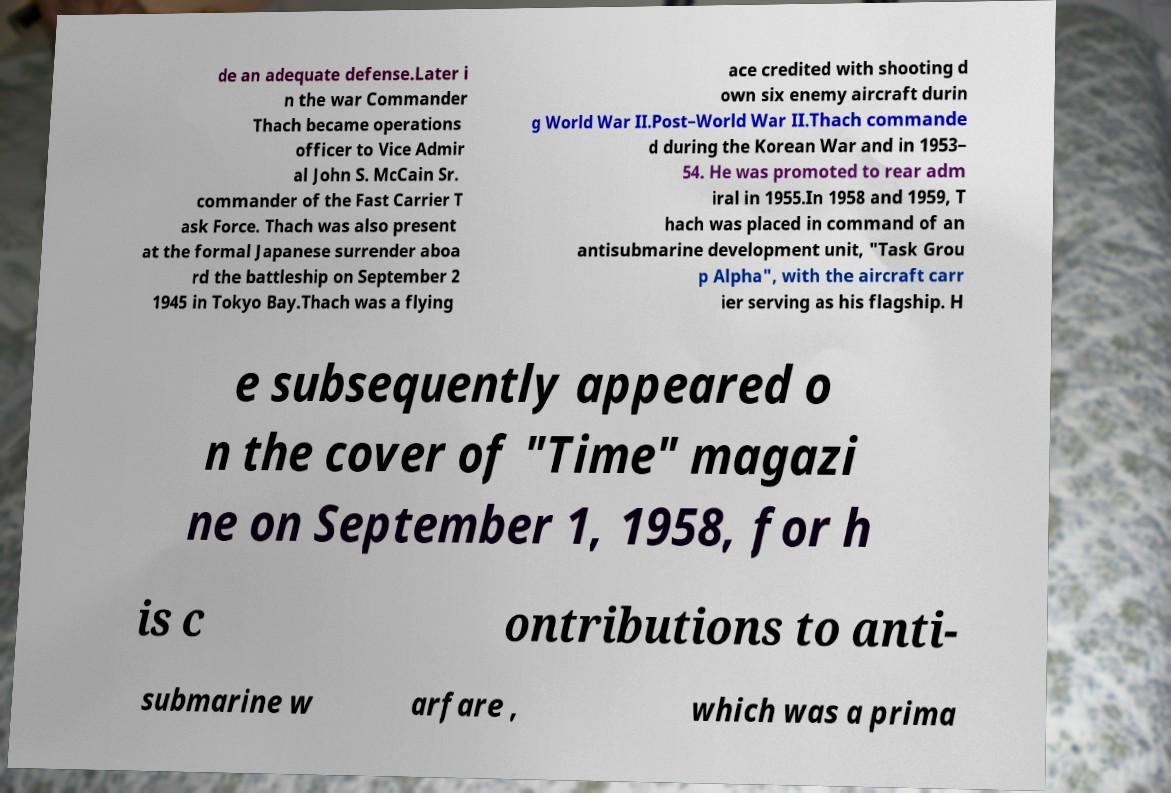Could you extract and type out the text from this image? de an adequate defense.Later i n the war Commander Thach became operations officer to Vice Admir al John S. McCain Sr. commander of the Fast Carrier T ask Force. Thach was also present at the formal Japanese surrender aboa rd the battleship on September 2 1945 in Tokyo Bay.Thach was a flying ace credited with shooting d own six enemy aircraft durin g World War II.Post–World War II.Thach commande d during the Korean War and in 1953– 54. He was promoted to rear adm iral in 1955.In 1958 and 1959, T hach was placed in command of an antisubmarine development unit, "Task Grou p Alpha", with the aircraft carr ier serving as his flagship. H e subsequently appeared o n the cover of "Time" magazi ne on September 1, 1958, for h is c ontributions to anti- submarine w arfare , which was a prima 